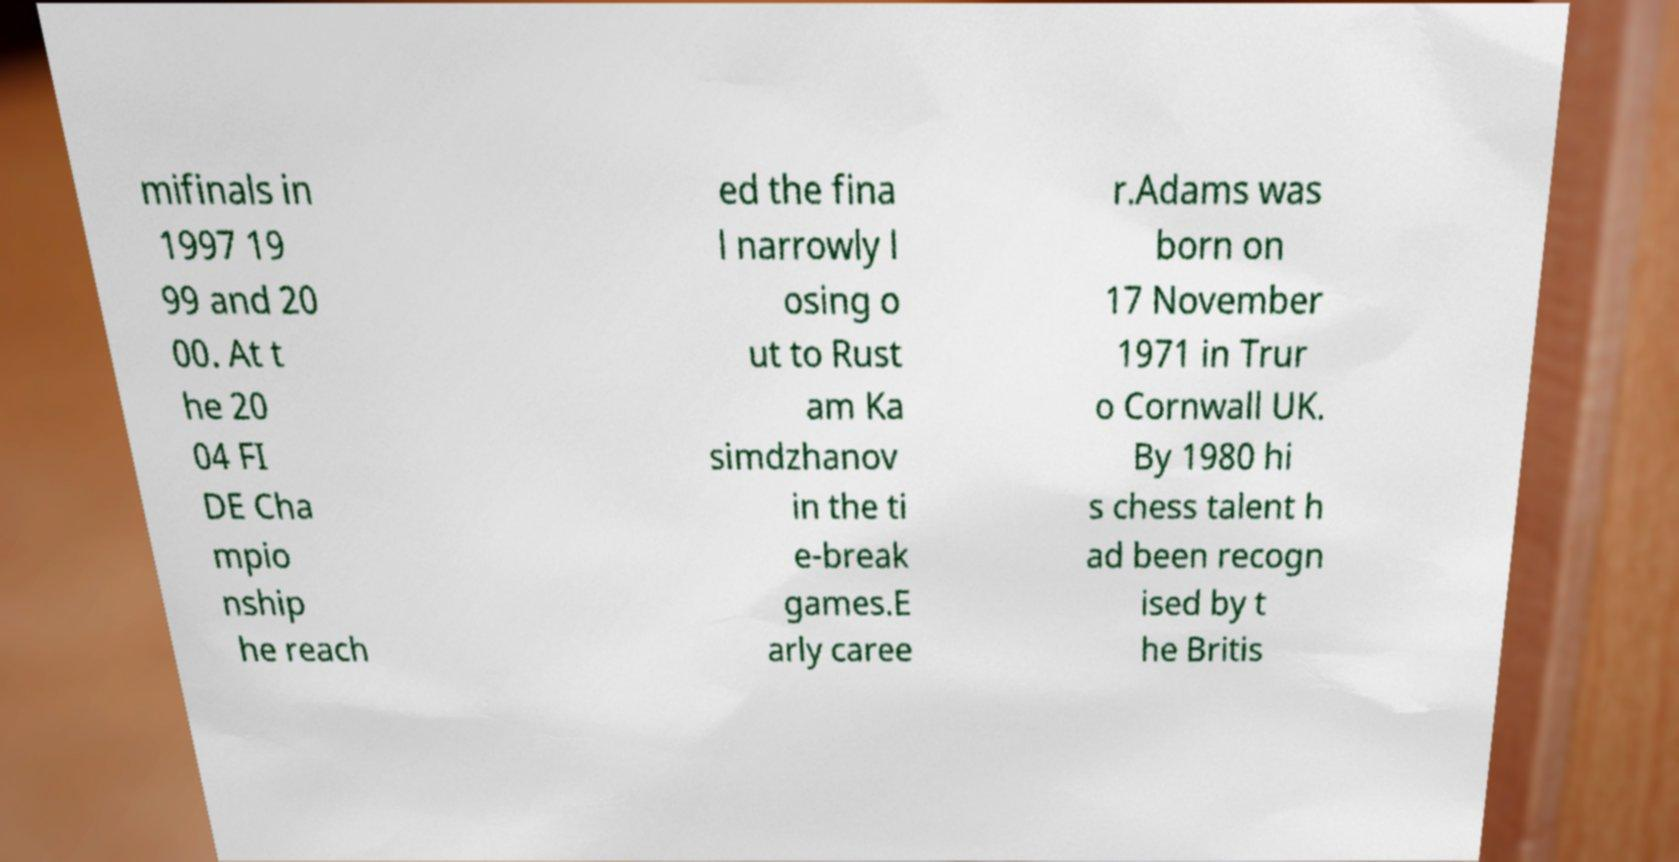I need the written content from this picture converted into text. Can you do that? mifinals in 1997 19 99 and 20 00. At t he 20 04 FI DE Cha mpio nship he reach ed the fina l narrowly l osing o ut to Rust am Ka simdzhanov in the ti e-break games.E arly caree r.Adams was born on 17 November 1971 in Trur o Cornwall UK. By 1980 hi s chess talent h ad been recogn ised by t he Britis 